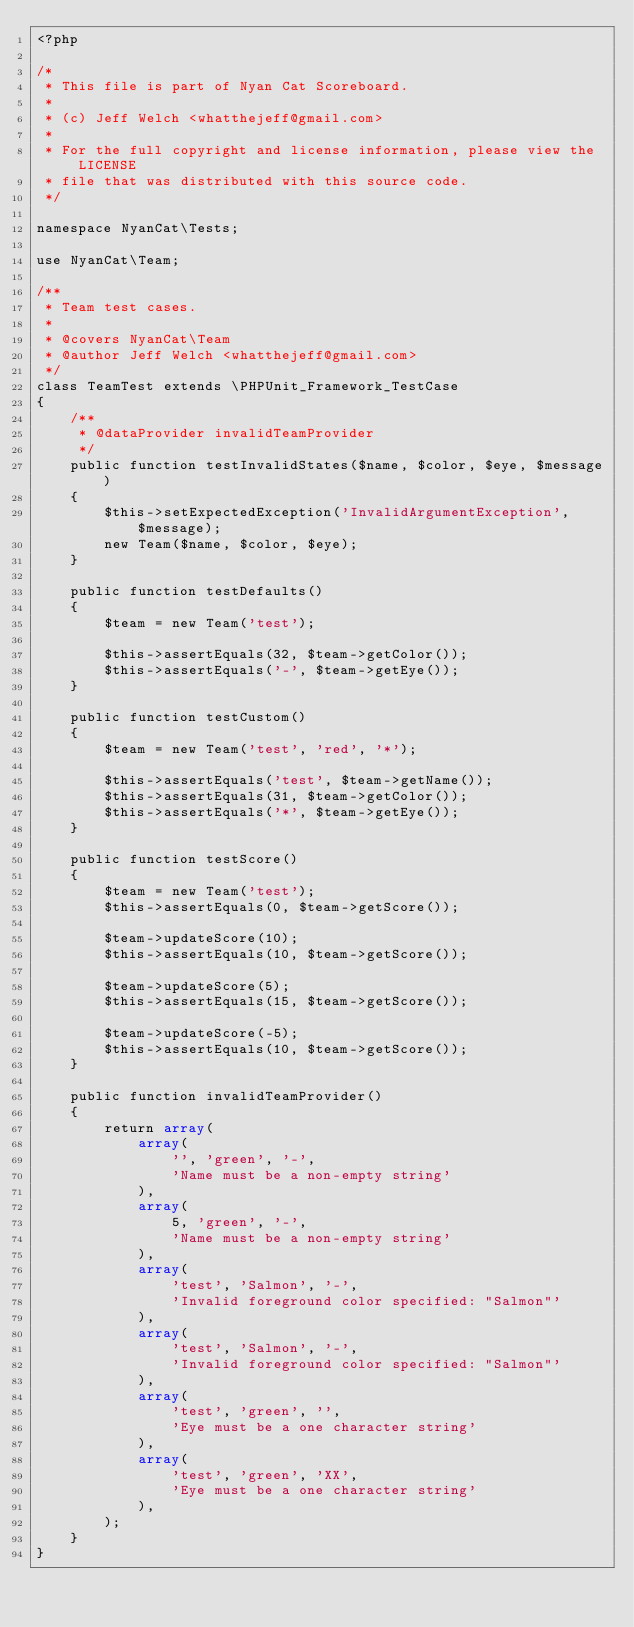Convert code to text. <code><loc_0><loc_0><loc_500><loc_500><_PHP_><?php

/*
 * This file is part of Nyan Cat Scoreboard.
 *
 * (c) Jeff Welch <whatthejeff@gmail.com>
 *
 * For the full copyright and license information, please view the LICENSE
 * file that was distributed with this source code.
 */

namespace NyanCat\Tests;

use NyanCat\Team;

/**
 * Team test cases.
 *
 * @covers NyanCat\Team
 * @author Jeff Welch <whatthejeff@gmail.com>
 */
class TeamTest extends \PHPUnit_Framework_TestCase
{
    /**
     * @dataProvider invalidTeamProvider
     */
    public function testInvalidStates($name, $color, $eye, $message)
    {
        $this->setExpectedException('InvalidArgumentException', $message);
        new Team($name, $color, $eye);
    }

    public function testDefaults()
    {
        $team = new Team('test');

        $this->assertEquals(32, $team->getColor());
        $this->assertEquals('-', $team->getEye());
    }

    public function testCustom()
    {
        $team = new Team('test', 'red', '*');

        $this->assertEquals('test', $team->getName());
        $this->assertEquals(31, $team->getColor());
        $this->assertEquals('*', $team->getEye());
    }

    public function testScore()
    {
        $team = new Team('test');
        $this->assertEquals(0, $team->getScore());

        $team->updateScore(10);
        $this->assertEquals(10, $team->getScore());

        $team->updateScore(5);
        $this->assertEquals(15, $team->getScore());

        $team->updateScore(-5);
        $this->assertEquals(10, $team->getScore());
    }

    public function invalidTeamProvider()
    {
        return array(
            array(
                '', 'green', '-',
                'Name must be a non-empty string'
            ),
            array(
                5, 'green', '-',
                'Name must be a non-empty string'
            ),
            array(
                'test', 'Salmon', '-',
                'Invalid foreground color specified: "Salmon"'
            ),
            array(
                'test', 'Salmon', '-',
                'Invalid foreground color specified: "Salmon"'
            ),
            array(
                'test', 'green', '',
                'Eye must be a one character string'
            ),
            array(
                'test', 'green', 'XX',
                'Eye must be a one character string'
            ),
        );
    }
}
</code> 